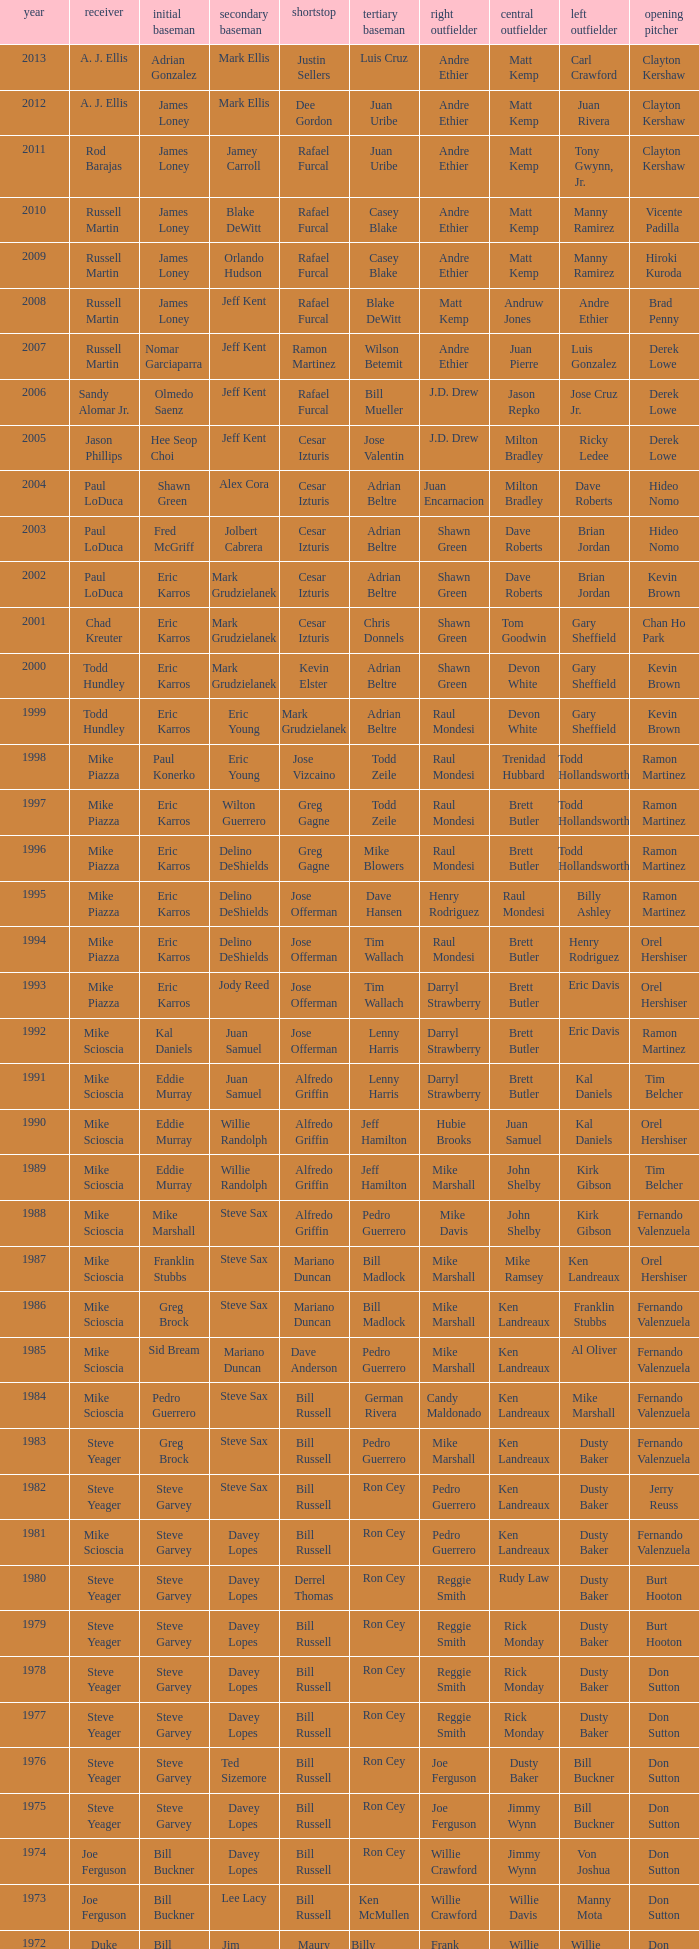Who played 2nd base when nomar garciaparra was at 1st base? Jeff Kent. 